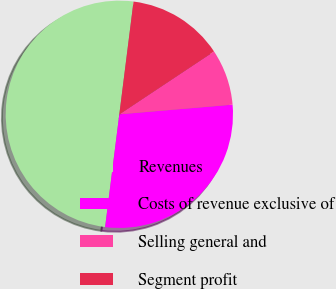Convert chart to OTSL. <chart><loc_0><loc_0><loc_500><loc_500><pie_chart><fcel>Revenues<fcel>Costs of revenue exclusive of<fcel>Selling general and<fcel>Segment profit<nl><fcel>50.0%<fcel>28.35%<fcel>7.98%<fcel>13.67%<nl></chart> 